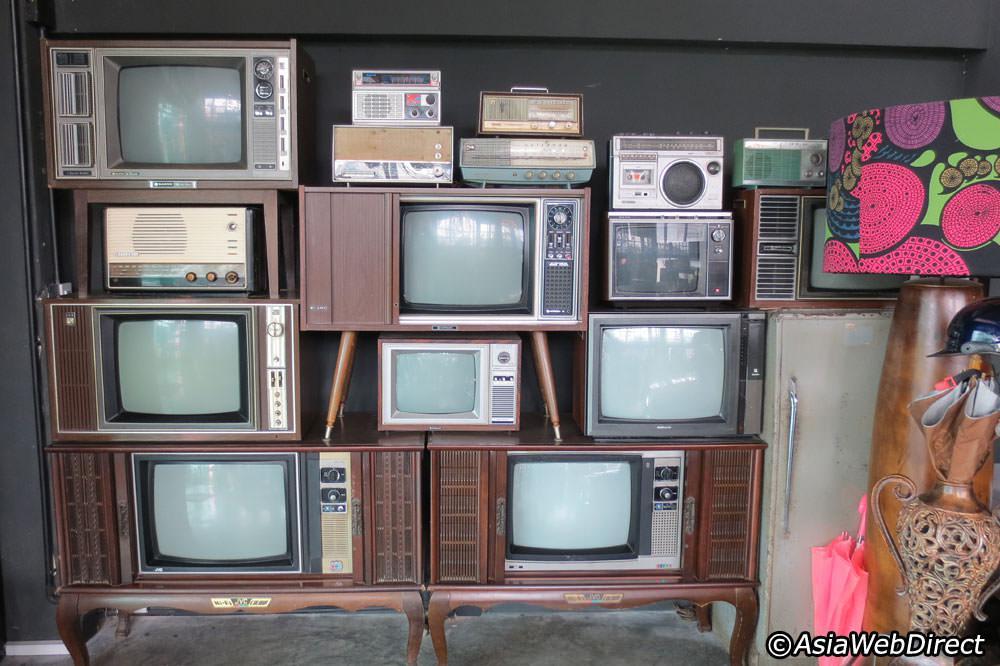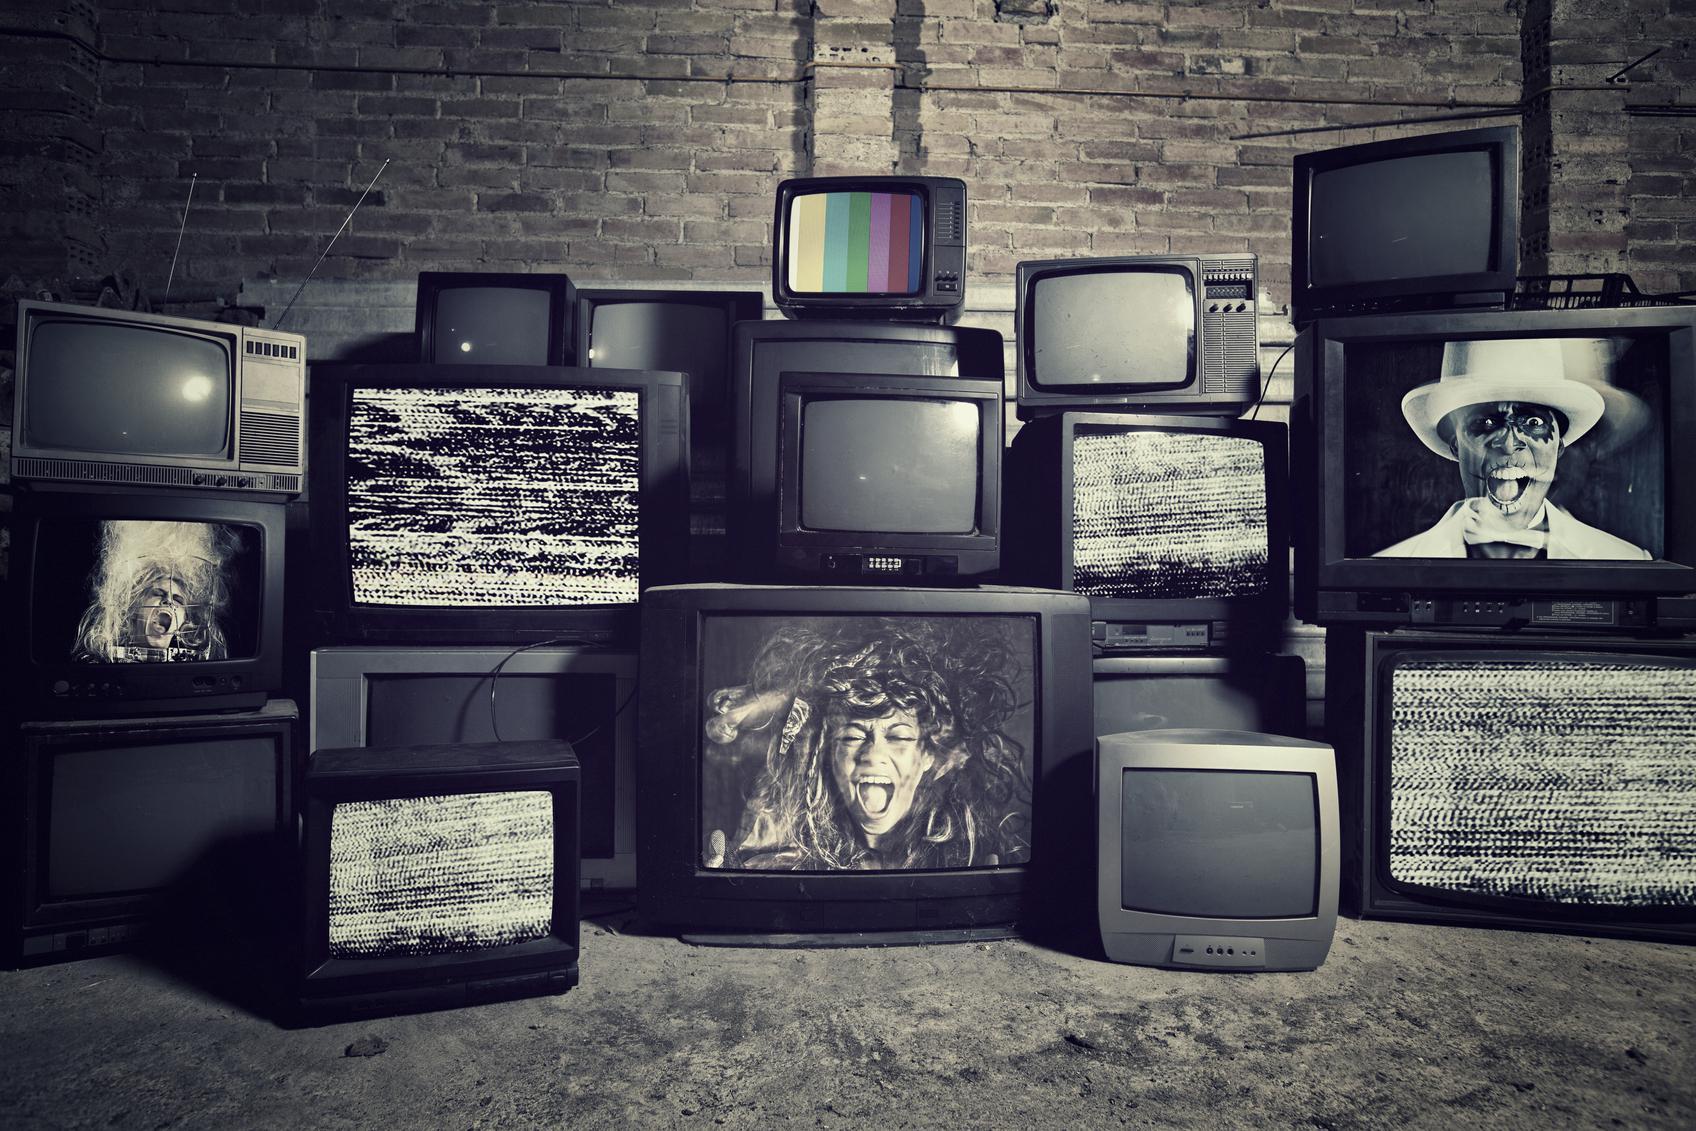The first image is the image on the left, the second image is the image on the right. Examine the images to the left and right. Is the description "Each image shows stacks of different model old-fashioned TV sets, and the right image includes some TVs with static on the screens." accurate? Answer yes or no. Yes. 